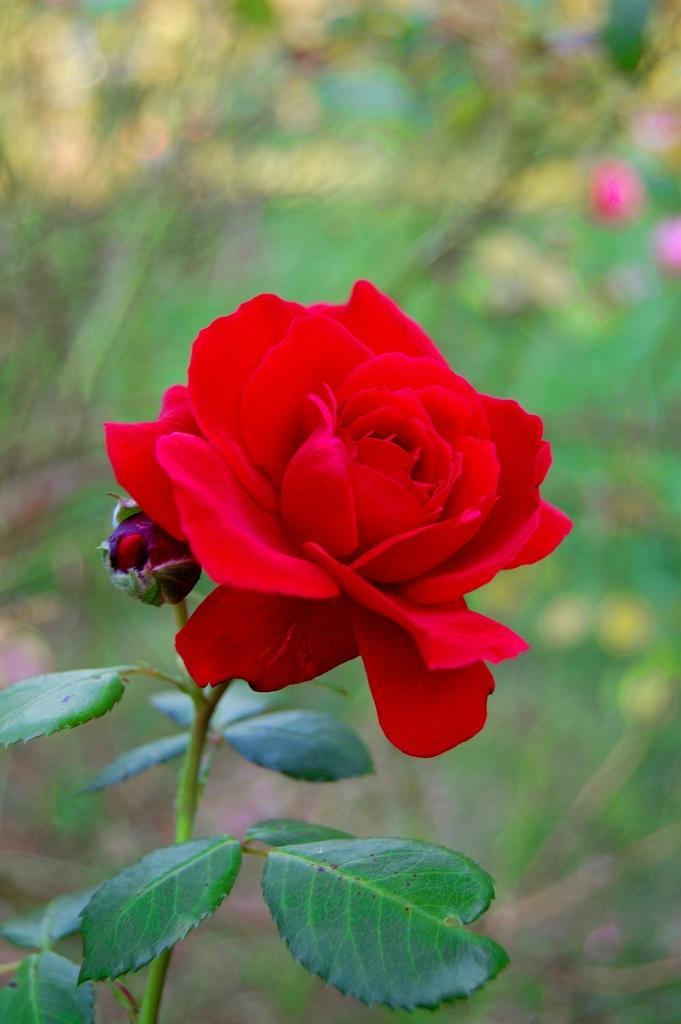Please provide a concise description of this image. In this image we can see a rose flower with a bud to the stem. 